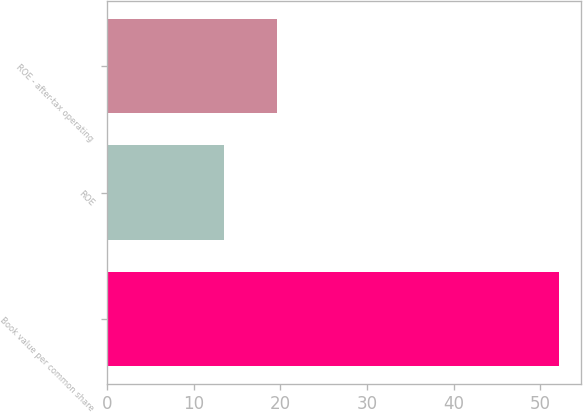<chart> <loc_0><loc_0><loc_500><loc_500><bar_chart><fcel>Book value per common share<fcel>ROE<fcel>ROE - after-tax operating<nl><fcel>52.12<fcel>13.52<fcel>19.64<nl></chart> 